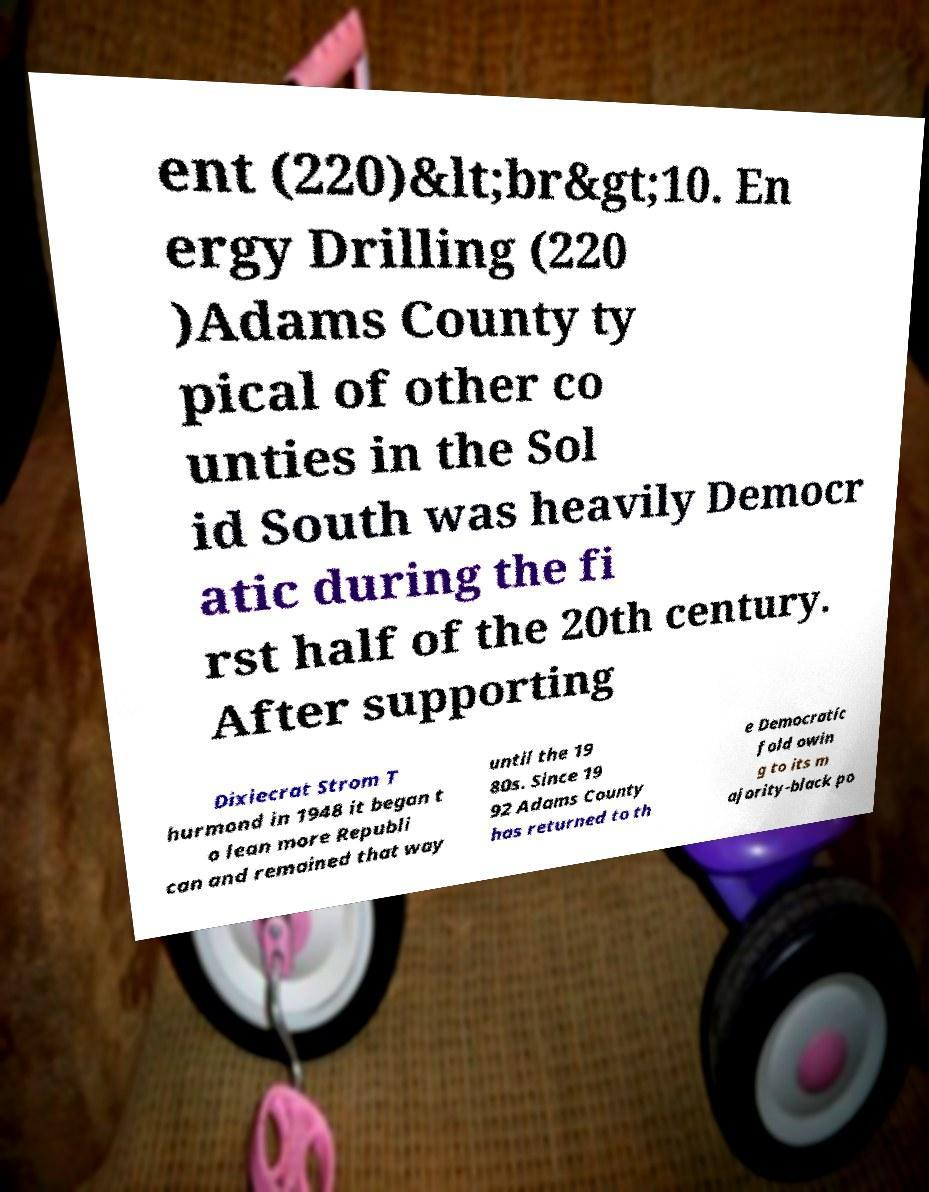Could you assist in decoding the text presented in this image and type it out clearly? ent (220)&lt;br&gt;10. En ergy Drilling (220 )Adams County ty pical of other co unties in the Sol id South was heavily Democr atic during the fi rst half of the 20th century. After supporting Dixiecrat Strom T hurmond in 1948 it began t o lean more Republi can and remained that way until the 19 80s. Since 19 92 Adams County has returned to th e Democratic fold owin g to its m ajority-black po 